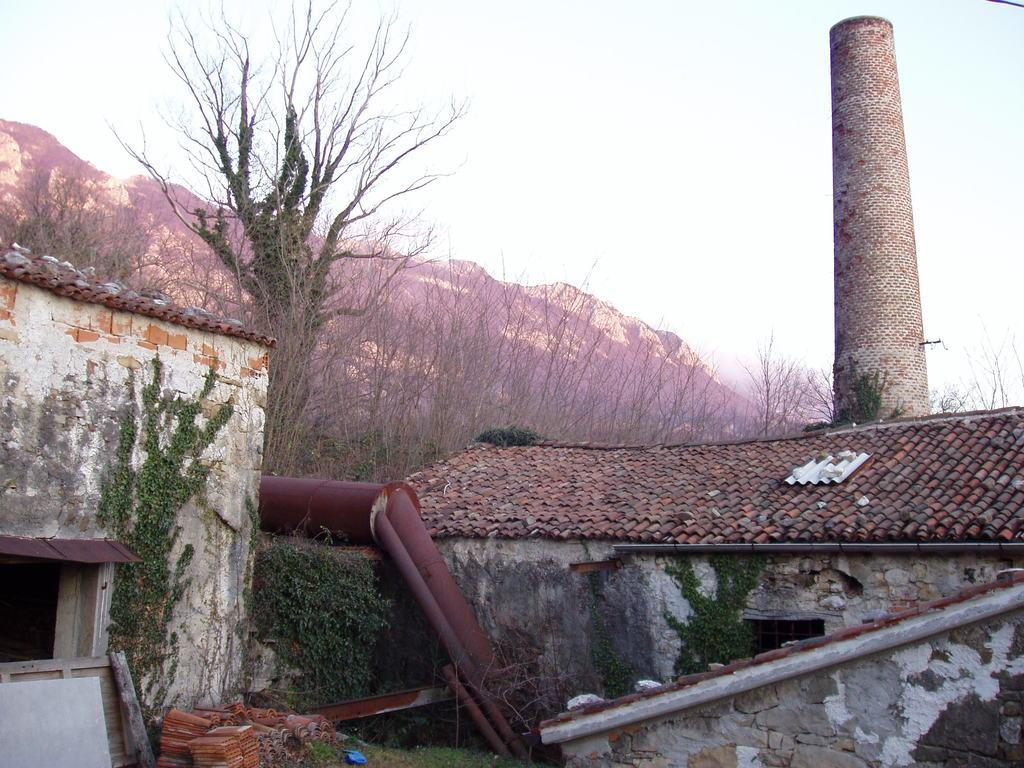What type of structures can be seen in the image? There are buildings in the image. What other natural elements are present in the image? There are plants, trees, and hills visible in the image. What part of the natural environment is visible in the image? The sky is visible in the image. What type of paper is being used to write the caption for the image? There is no caption present in the image, so it is not possible to determine what type of paper might be used. 